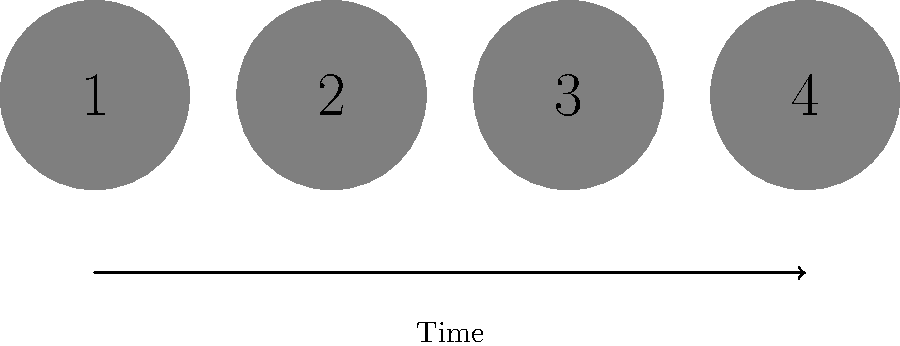In Richard Armitage's dance video appearances, the silhouettes above represent his dance partners in chronological order. Which number corresponds to the silhouette of his partner in the "Staged" music video by Audrey Gallagher? To answer this question, we need to recall Richard Armitage's dance video appearances chronologically:

1. The first silhouette represents his partner in the "Wolves" music video by Horses Brawl (2004).
2. The second silhouette corresponds to his partner in the "Spinning" music video by Crucified Barbara (2006).
3. The third silhouette represents Audrey Gallagher, his partner in the "Staged" music video (2009).
4. The fourth silhouette is his partner in the "Pilgrimage" music video by Gavin Sutherland (2012).

Since the question asks specifically about the "Staged" music video by Audrey Gallagher, we need to identify the third silhouette in the chronological order.
Answer: 3 